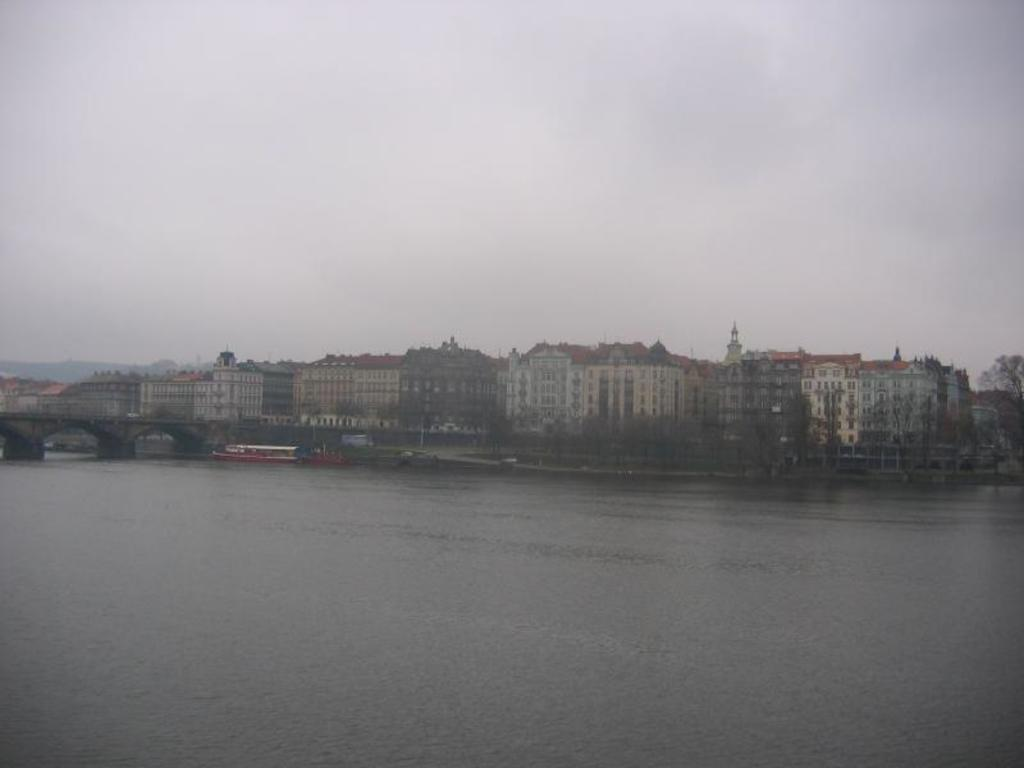What type of structures can be seen in the image? There are buildings in the image. What connects the two sides of the river in the image? There is a bridge over a river in the image. What type of vehicles can be seen in the image? Ships are visible in the image. What type of natural feature can be seen in the image? There are hills in the image. What is visible in the sky in the image? The sky is visible in the image, and clouds are present. Can you touch the word "bridge" in the image? There is no word "bridge" present in the image; it is a visual representation of a bridge. What type of insect can be seen flying over the river in the image? There are no insects visible in the image. 